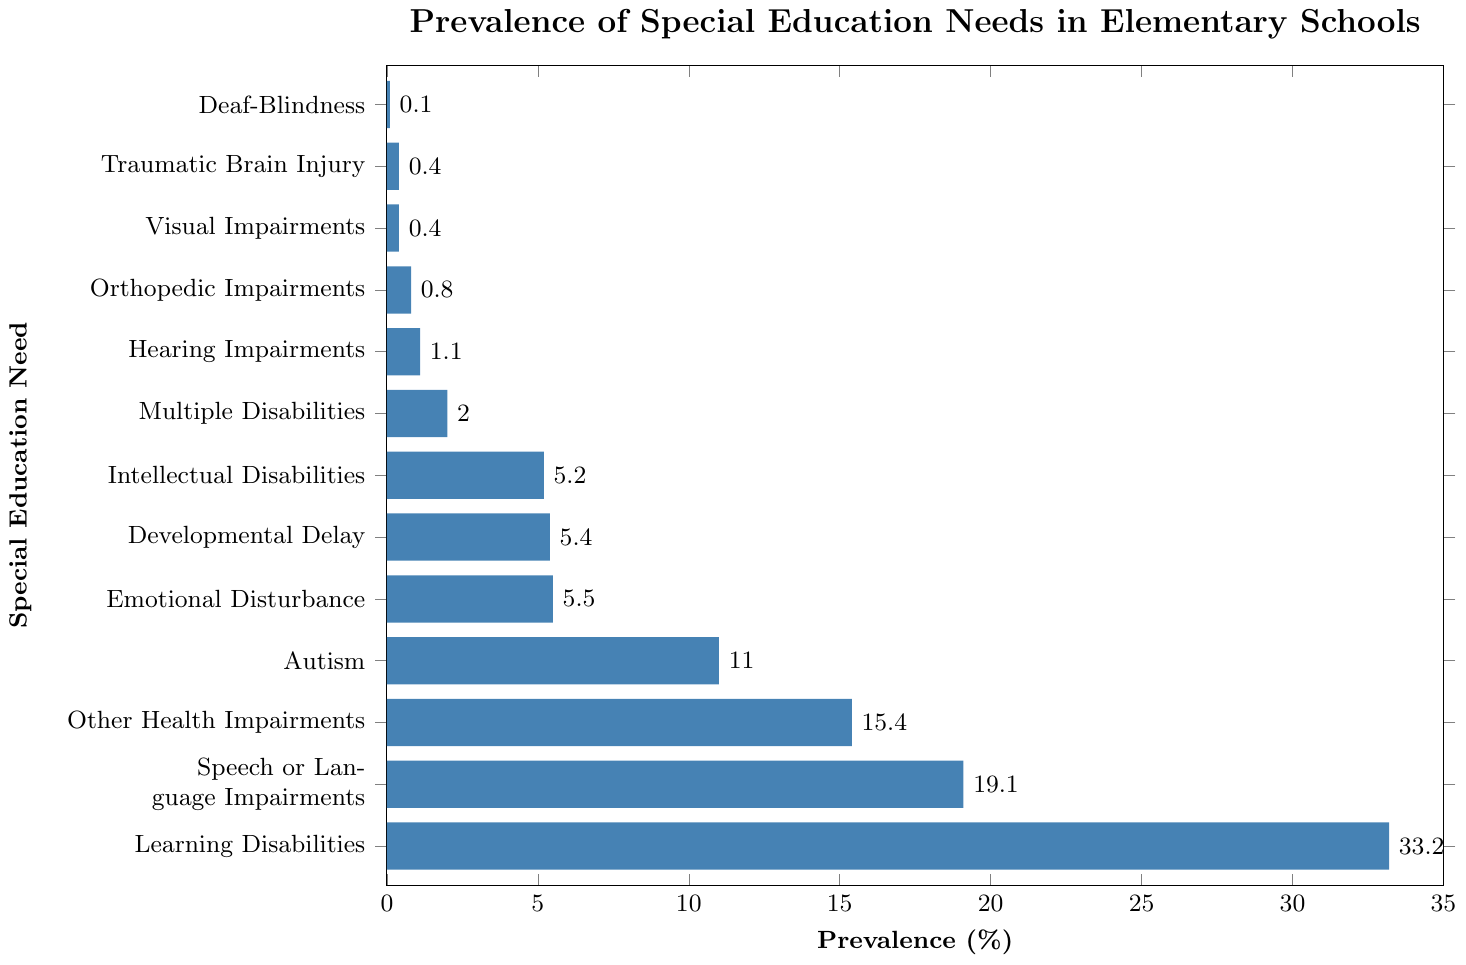How prevalent are Learning Disabilities compared to Speech or Language Impairments? Learning Disabilities have a prevalence of 33.2% while Speech or Language Impairments have a prevalence of 19.1%. To compare: 33.2% is greater than 19.1%.
Answer: 33.2% is greater Which special education need has the lowest prevalence? The figure shows the prevalence percentages next to each special education need. The lowest prevalence is for Deaf-Blindness, which is 0.1%.
Answer: Deaf-Blindness What is the combined prevalence of Autism, Emotional Disturbance, and Developmental Delay? The prevalence values for Autism (11.0%), Emotional Disturbance (5.5%), and Developmental Delay (5.4%) are summed: 11.0 + 5.5 + 5.4 = 21.9%.
Answer: 21.9% How many categories have a prevalence of over 10%? From the figure, three categories have a prevalence over 10%: Learning Disabilities (33.2%), Speech or Language Impairments (19.1%), and Other Health Impairments (15.4%).
Answer: 3 Is the prevalence of Orthopedic Impairments greater than Visual Impairments? Orthopedic Impairments have a prevalence of 0.8%, while Visual Impairments have a prevalence of 0.4%. To compare: 0.8 is greater than 0.4.
Answer: Yes Which special education need has a prevalence just under 20%? The figure shows that Speech or Language Impairments have a prevalence of 19.1%, which is just under 20%.
Answer: Speech or Language Impairments What is the difference in prevalence between Intellectual Disabilities and Multiple Disabilities? Intellectual Disabilities have a prevalence of 5.2%, and Multiple Disabilities have a prevalence of 2.0%. The difference is calculated as 5.2 - 2.0 = 3.2%.
Answer: 3.2% If the proportions of categories below 1% were combined, what would be the total prevalence? Below 1% are Visual Impairments (0.4%), Traumatic Brain Injury (0.4%), and Deaf-Blindness (0.1%). Combined, the prevalence is 0.4 + 0.4 + 0.1 = 0.9%.
Answer: 0.9% What proportion of the total set do Learning Disabilities and Speech or Language Impairments constitute together? Learning Disabilities (33.2%) and Speech or Language Impairments (19.1%) combined are 33.2 + 19.1 = 52.3%.
Answer: 52.3% Which special education needs are more prevalent than Autism but less prevalent than Learning Disabilities? Other Health Impairments (15.4%) and Speech or Language Impairments (19.1%) fall between Autism (11.0%) and Learning Disabilities (33.2%).
Answer: Other Health Impairments and Speech or Language Impairments 